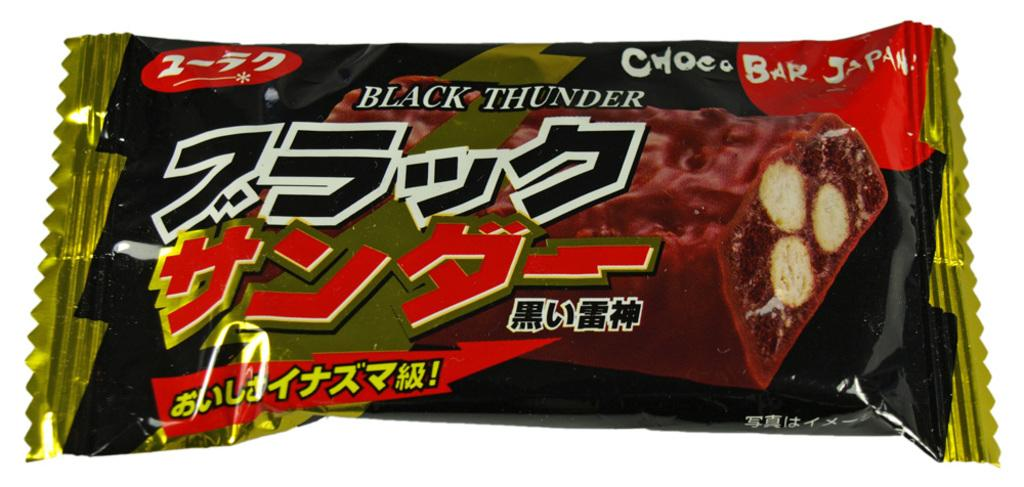What object is visible in the image? There is a chocolate wrapper in the image. What color is the background of the image? The background of the image is white. What type of insurance is being discussed in the image? There is no discussion of insurance in the image; it only features a chocolate wrapper and a white background. 